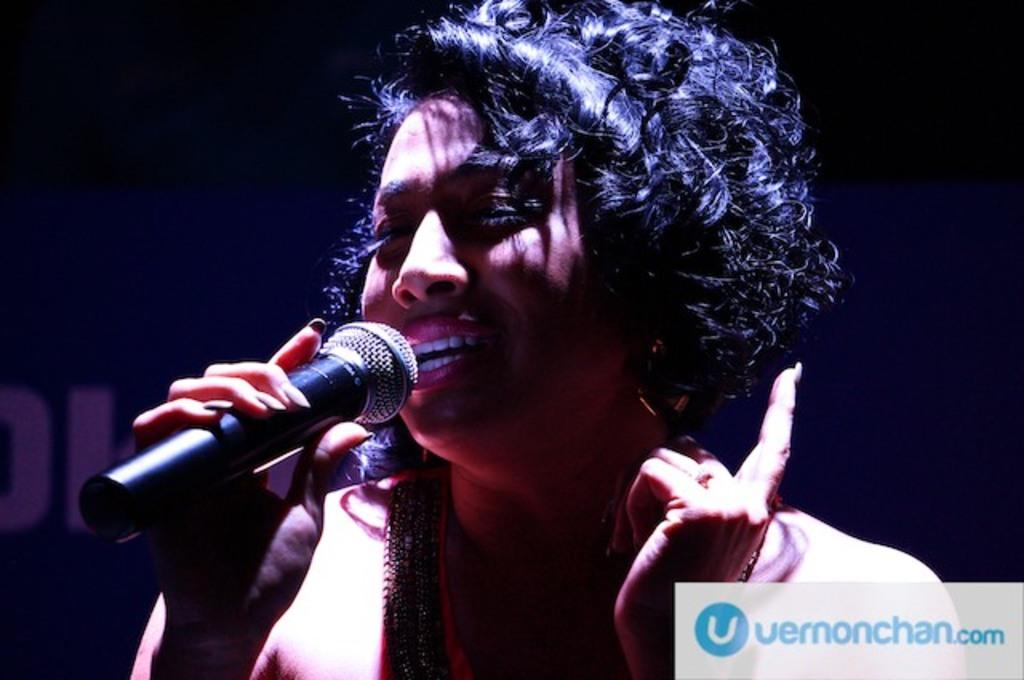What is the main subject of the image? The main subject of the image is a woman. Can you describe the woman's position in the image? The woman is standing in the middle of the image. What is the woman holding in the image? The woman is holding a microphone. What is the woman doing in the image? The woman is singing. Can you tell me what type of board the woman is standing on in the image? There is no board present in the image; the woman is standing on the ground. What type of locket is the woman wearing around her neck in the image? There is no locket visible in the image. 